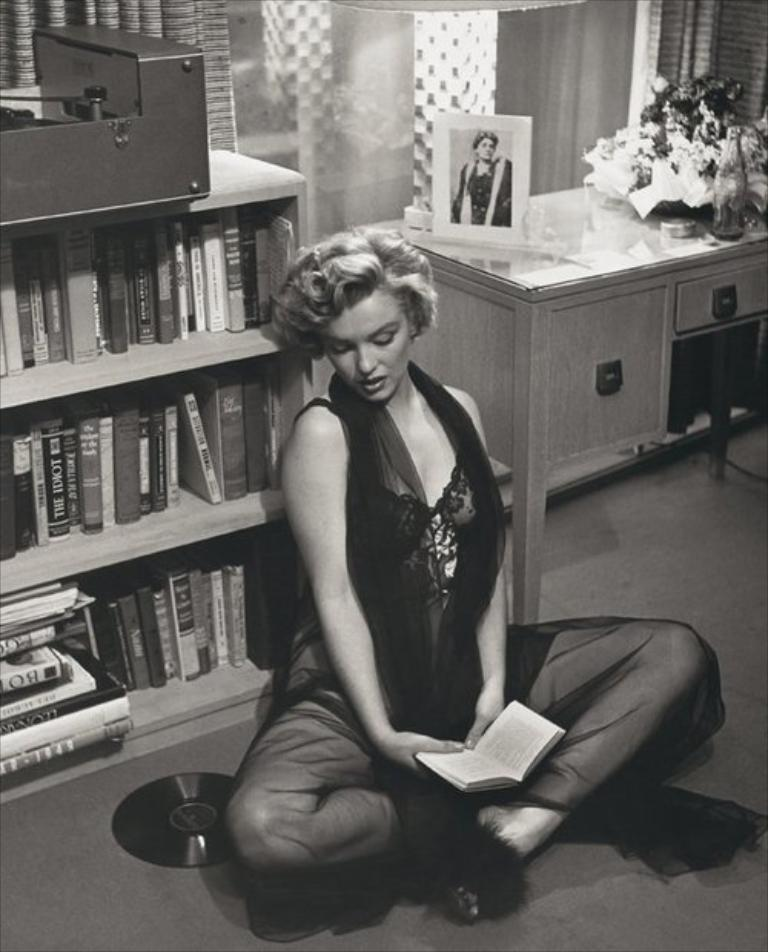What is the woman in the image doing? The woman is sitting in the middle of the image and holding a book. What can be seen behind the woman? There is a bookshelf and a table behind the woman. What is on the table? There is a frame, flowers, and a bottle on the table. What class is the woman teaching in the image? There is no indication in the image that the woman is teaching a class. What thought is the woman having while holding the book? The image does not provide information about the woman's thoughts, so it cannot be determined from the image. 